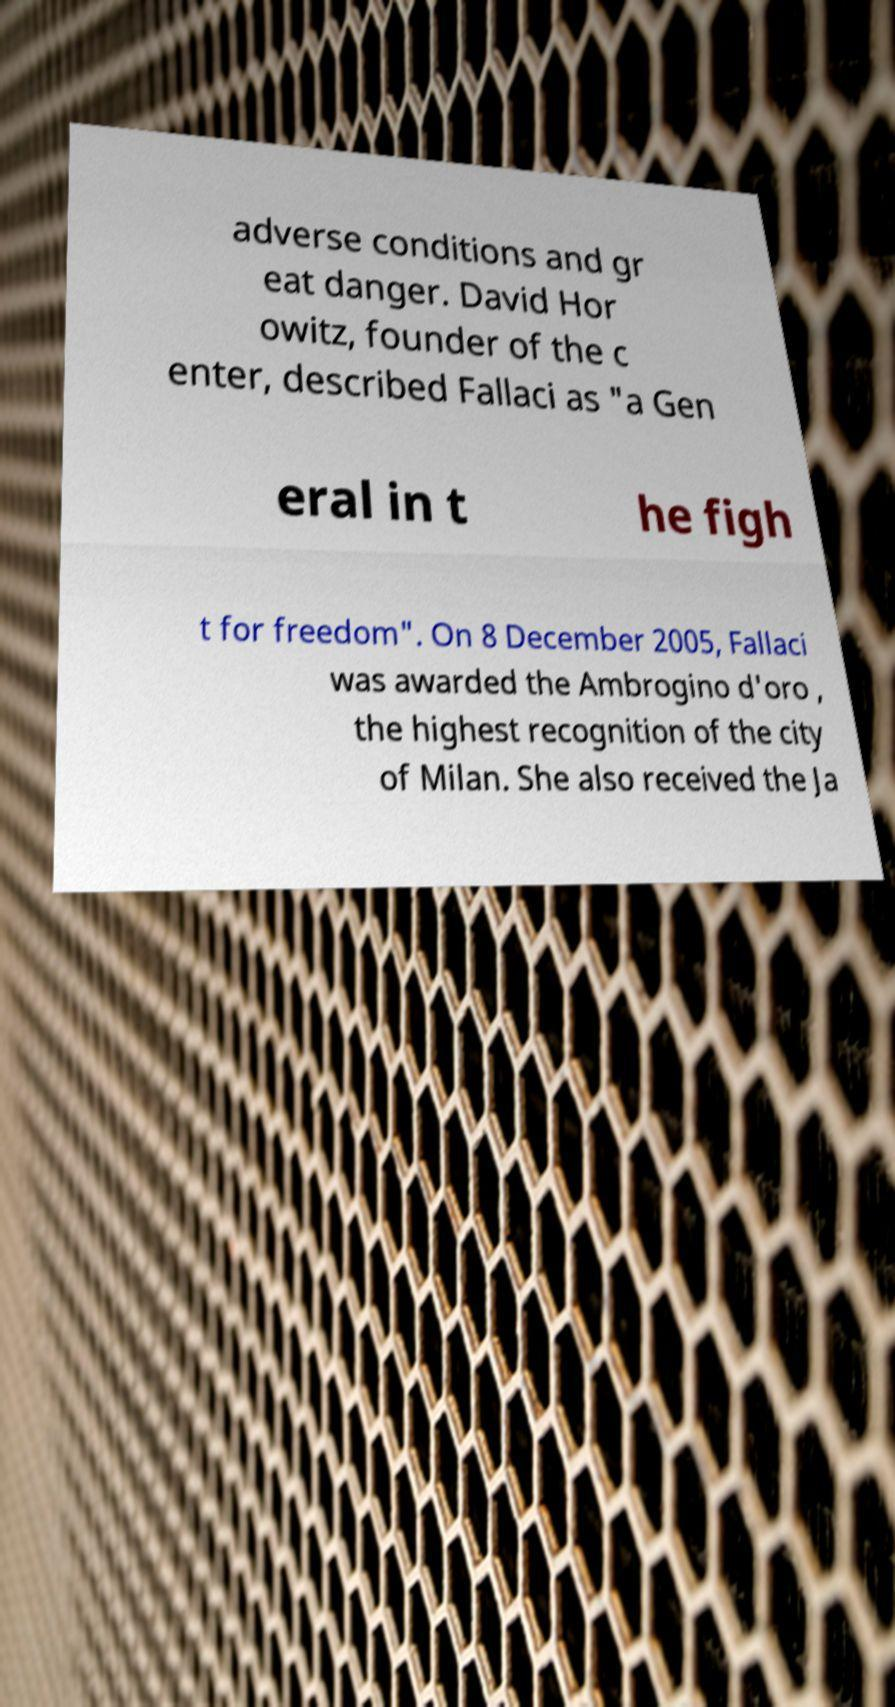Please read and relay the text visible in this image. What does it say? adverse conditions and gr eat danger. David Hor owitz, founder of the c enter, described Fallaci as "a Gen eral in t he figh t for freedom". On 8 December 2005, Fallaci was awarded the Ambrogino d'oro , the highest recognition of the city of Milan. She also received the Ja 